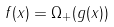<formula> <loc_0><loc_0><loc_500><loc_500>f ( x ) = \Omega _ { + } ( g ( x ) )</formula> 